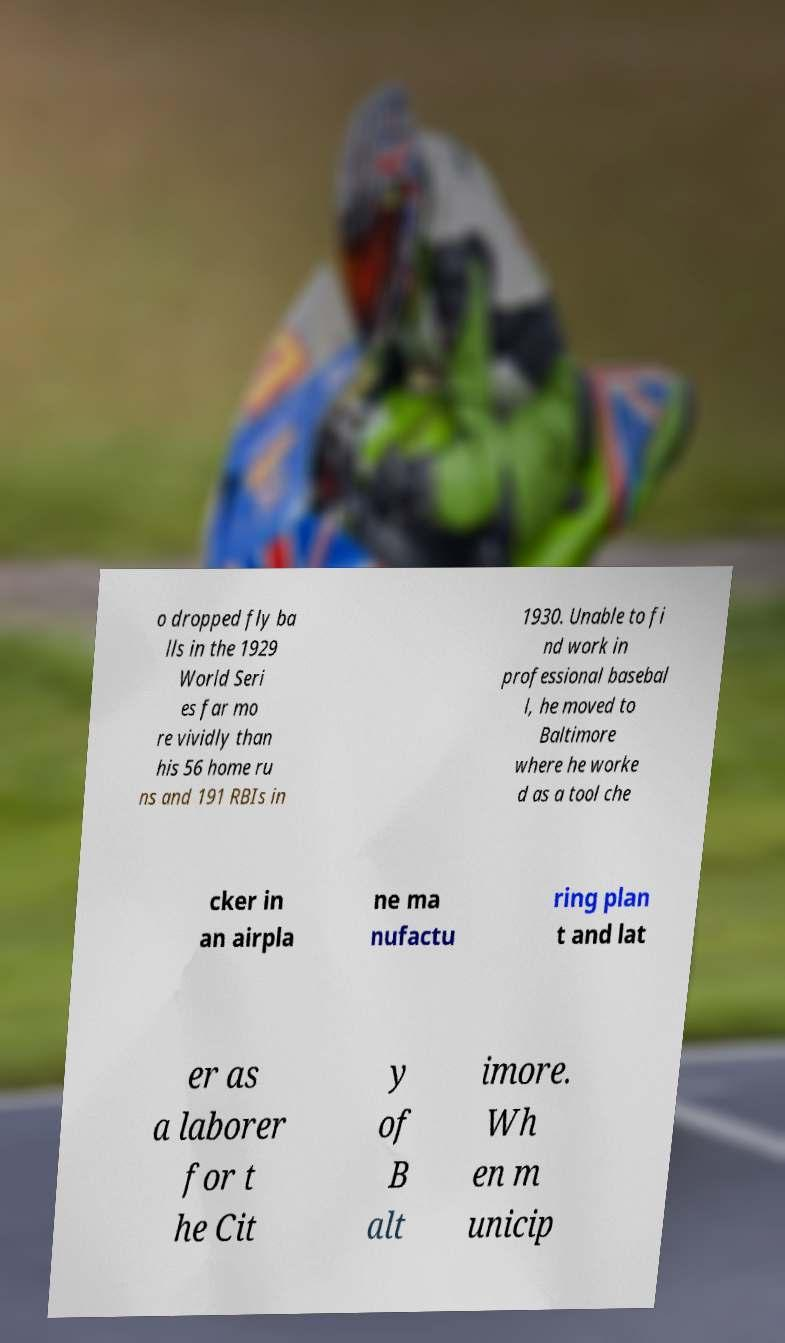Can you accurately transcribe the text from the provided image for me? o dropped fly ba lls in the 1929 World Seri es far mo re vividly than his 56 home ru ns and 191 RBIs in 1930. Unable to fi nd work in professional basebal l, he moved to Baltimore where he worke d as a tool che cker in an airpla ne ma nufactu ring plan t and lat er as a laborer for t he Cit y of B alt imore. Wh en m unicip 